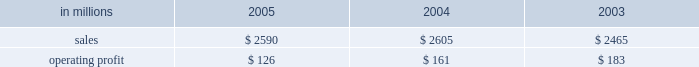Entering 2006 , industrial packaging earnings are expected to improve significantly in the first quarter compared with the fourth quarter 2005 .
Average price realizations should continue to benefit from price in- creases announced in late 2005 and early 2006 for linerboard and domestic boxes .
Containerboard sales volumes are expected to drop slightly in the 2006 first quarter due to fewer shipping days , but growth is antici- pated for u.s .
Converted products due to stronger de- mand .
Costs for wood , freight and energy are expected to remain stable during the 2006 first quarter , approach- ing fourth quarter 2005 levels .
The continued im- plementation of the new supply chain model at our mills during 2006 will bring additional efficiency improve- ments and cost savings .
On a global basis , the european container operating results are expected to improve as a result of targeted market growth and cost reduction ini- tiatives , and we will begin seeing further contributions from our recent moroccan box plant acquisition and from international paper distribution limited .
Consumer packaging demand and pricing for consumer packaging prod- ucts correlate closely with consumer spending and gen- eral economic activity .
In addition to prices and volumes , major factors affecting the profitability of con- sumer packaging are raw material and energy costs , manufacturing efficiency and product mix .
Consumer packaging 2019s 2005 net sales of $ 2.6 bil- lion were flat compared with 2004 and 5% ( 5 % ) higher com- pared with 2003 .
Operating profits in 2005 declined 22% ( 22 % ) from 2004 and 31% ( 31 % ) from 2003 as improved price realizations ( $ 46 million ) and favorable operations in the mills and converting operations ( $ 60 million ) could not overcome the impact of cost increases in energy , wood , polyethylene and other raw materials ( $ 120 million ) , lack-of-order downtime ( $ 13 million ) and other costs ( $ 8 million ) .
Consumer packaging in millions 2005 2004 2003 .
Bleached board net sales of $ 864 million in 2005 were up from $ 842 million in 2004 and $ 751 million in 2003 .
The effects in 2005 of improved average price realizations and mill operating improvements were not enough to offset increased energy , wood , polyethylene and other raw material costs , a slight decrease in volume and increased lack-of-order downtime .
Bleached board mills took 100000 tons of downtime in 2005 , including 65000 tons of lack-of-order downtime , compared with 40000 tons of downtime in 2004 , none of which was market related .
During 2005 , restructuring and manufacturing improvement plans were implemented to reduce costs and improve market alignment .
Foodservice net sales were $ 437 million in 2005 compared with $ 480 million in 2004 and $ 460 million in 2003 .
Average sales prices in 2005 were up 3% ( 3 % ) ; how- ever , domestic cup and lid sales volumes were 5% ( 5 % ) lower than in 2004 as a result of a rationalization of our cus- tomer base early in 2005 .
Operating profits in 2005 in- creased 147% ( 147 % ) compared with 2004 , largely due to the settlement of a lawsuit and a favorable adjustment on the sale of the jackson , tennessee bag plant .
Excluding unusual items , operating profits were flat as improved price realizations offset increased costs for bleached board and resin .
Shorewood net sales of $ 691 million in 2005 were essentially flat with net sales in 2004 of $ 687 million , but were up compared with $ 665 million in 2003 .
Operating profits in 2005 were 17% ( 17 % ) above 2004 levels and about equal to 2003 levels .
Improved margins resulting from a rationalization of the customer mix and the effects of improved manufacturing operations , including the successful start up of our south korean tobacco operations , more than offset cost increases for board and paper and the impact of unfavorable foreign exchange rates in canada .
Beverage packaging net sales were $ 597 million in 2005 , $ 595 million in 2004 and $ 589 million in 2003 .
Average sale price realizations increased 2% ( 2 % ) compared with 2004 , principally the result of the pass-through of higher raw material costs , although the implementation of price increases continues to be impacted by com- petitive pressures .
Operating profits were down 14% ( 14 % ) compared with 2004 and 19% ( 19 % ) compared with 2003 , due principally to increases in board and resin costs .
In 2006 , the bleached board market is expected to remain strong , with sales volumes increasing in the first quarter compared with the fourth quarter of 2005 for both folding carton and cup products .
Improved price realizations are also expected for bleached board and in our foodservice and beverage packaging businesses , al- though continued high costs for energy , wood and resin will continue to negatively impact earnings .
Shorewood should continue to benefit from strong asian operations and from targeted sales volume growth in 2006 .
Capital improvements and operational excellence initiatives undertaken in 2005 should benefit operating results in 2006 for all businesses .
Distribution our distribution business , principally represented by our xpedx business , markets a diverse array of products and supply chain services to customers in many business segments .
Customer demand is generally sensitive to changes in general economic conditions , although the .
What was the average shorewood net sales from 2003 to 2005 in millions? 
Computations: (((665 + (691 + 687)) + 3) / 2)
Answer: 1023.0. 